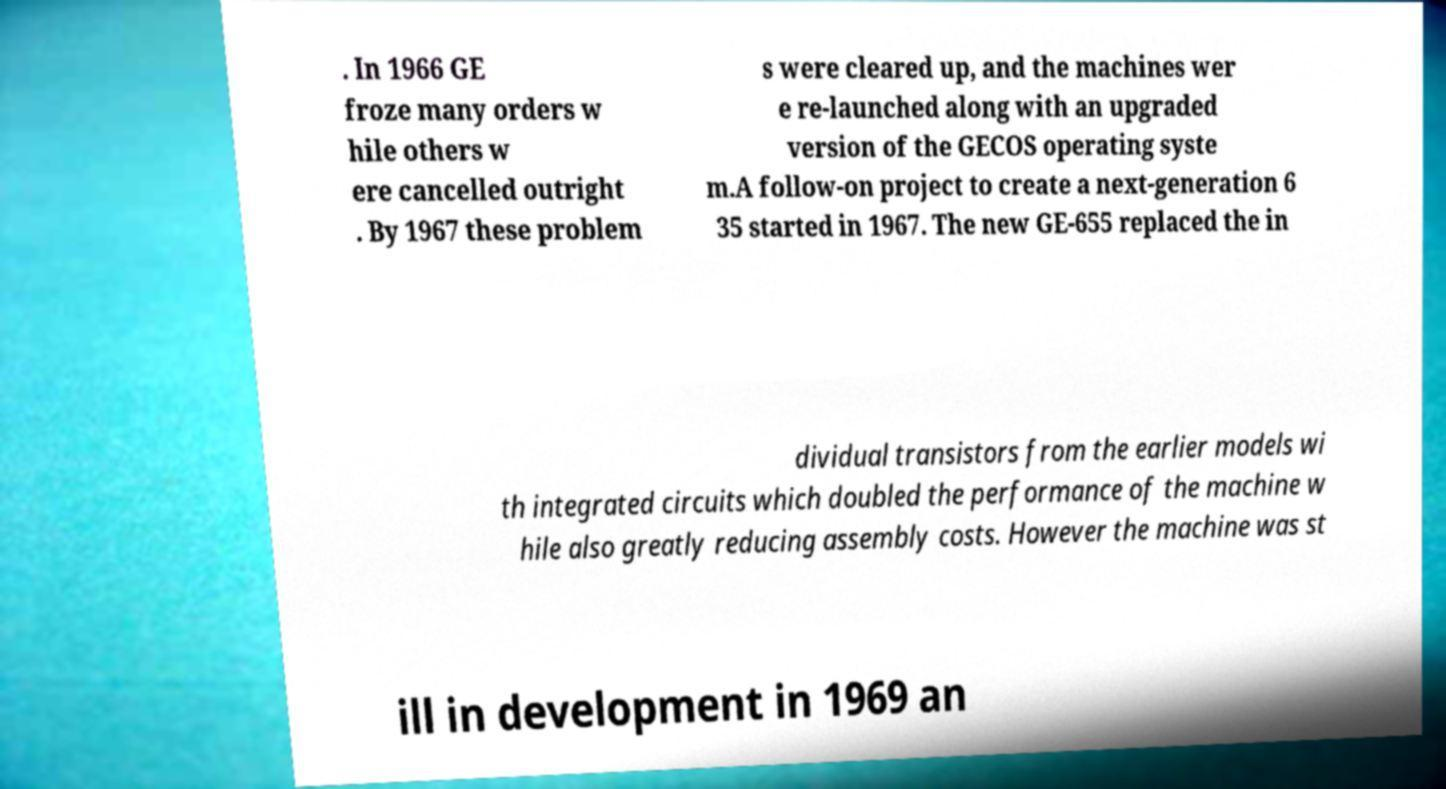Can you read and provide the text displayed in the image?This photo seems to have some interesting text. Can you extract and type it out for me? . In 1966 GE froze many orders w hile others w ere cancelled outright . By 1967 these problem s were cleared up, and the machines wer e re-launched along with an upgraded version of the GECOS operating syste m.A follow-on project to create a next-generation 6 35 started in 1967. The new GE-655 replaced the in dividual transistors from the earlier models wi th integrated circuits which doubled the performance of the machine w hile also greatly reducing assembly costs. However the machine was st ill in development in 1969 an 